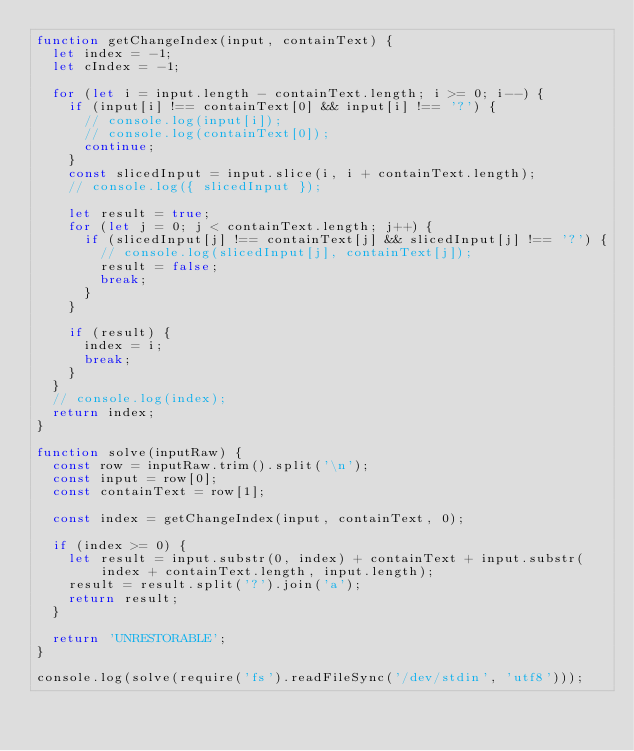<code> <loc_0><loc_0><loc_500><loc_500><_JavaScript_>function getChangeIndex(input, containText) {
  let index = -1;
  let cIndex = -1;

  for (let i = input.length - containText.length; i >= 0; i--) {
    if (input[i] !== containText[0] && input[i] !== '?') {
      // console.log(input[i]);
      // console.log(containText[0]);
      continue;
    }
    const slicedInput = input.slice(i, i + containText.length);
    // console.log({ slicedInput });

    let result = true;
    for (let j = 0; j < containText.length; j++) {
      if (slicedInput[j] !== containText[j] && slicedInput[j] !== '?') {
        // console.log(slicedInput[j], containText[j]);
        result = false;
        break;
      }
    }

    if (result) {
      index = i;
      break;
    }
  }
  // console.log(index);
  return index;
}

function solve(inputRaw) {
  const row = inputRaw.trim().split('\n');
  const input = row[0];
  const containText = row[1];

  const index = getChangeIndex(input, containText, 0);

  if (index >= 0) {
    let result = input.substr(0, index) + containText + input.substr(index + containText.length, input.length);
    result = result.split('?').join('a');
    return result;
  }

  return 'UNRESTORABLE';
}

console.log(solve(require('fs').readFileSync('/dev/stdin', 'utf8')));
</code> 